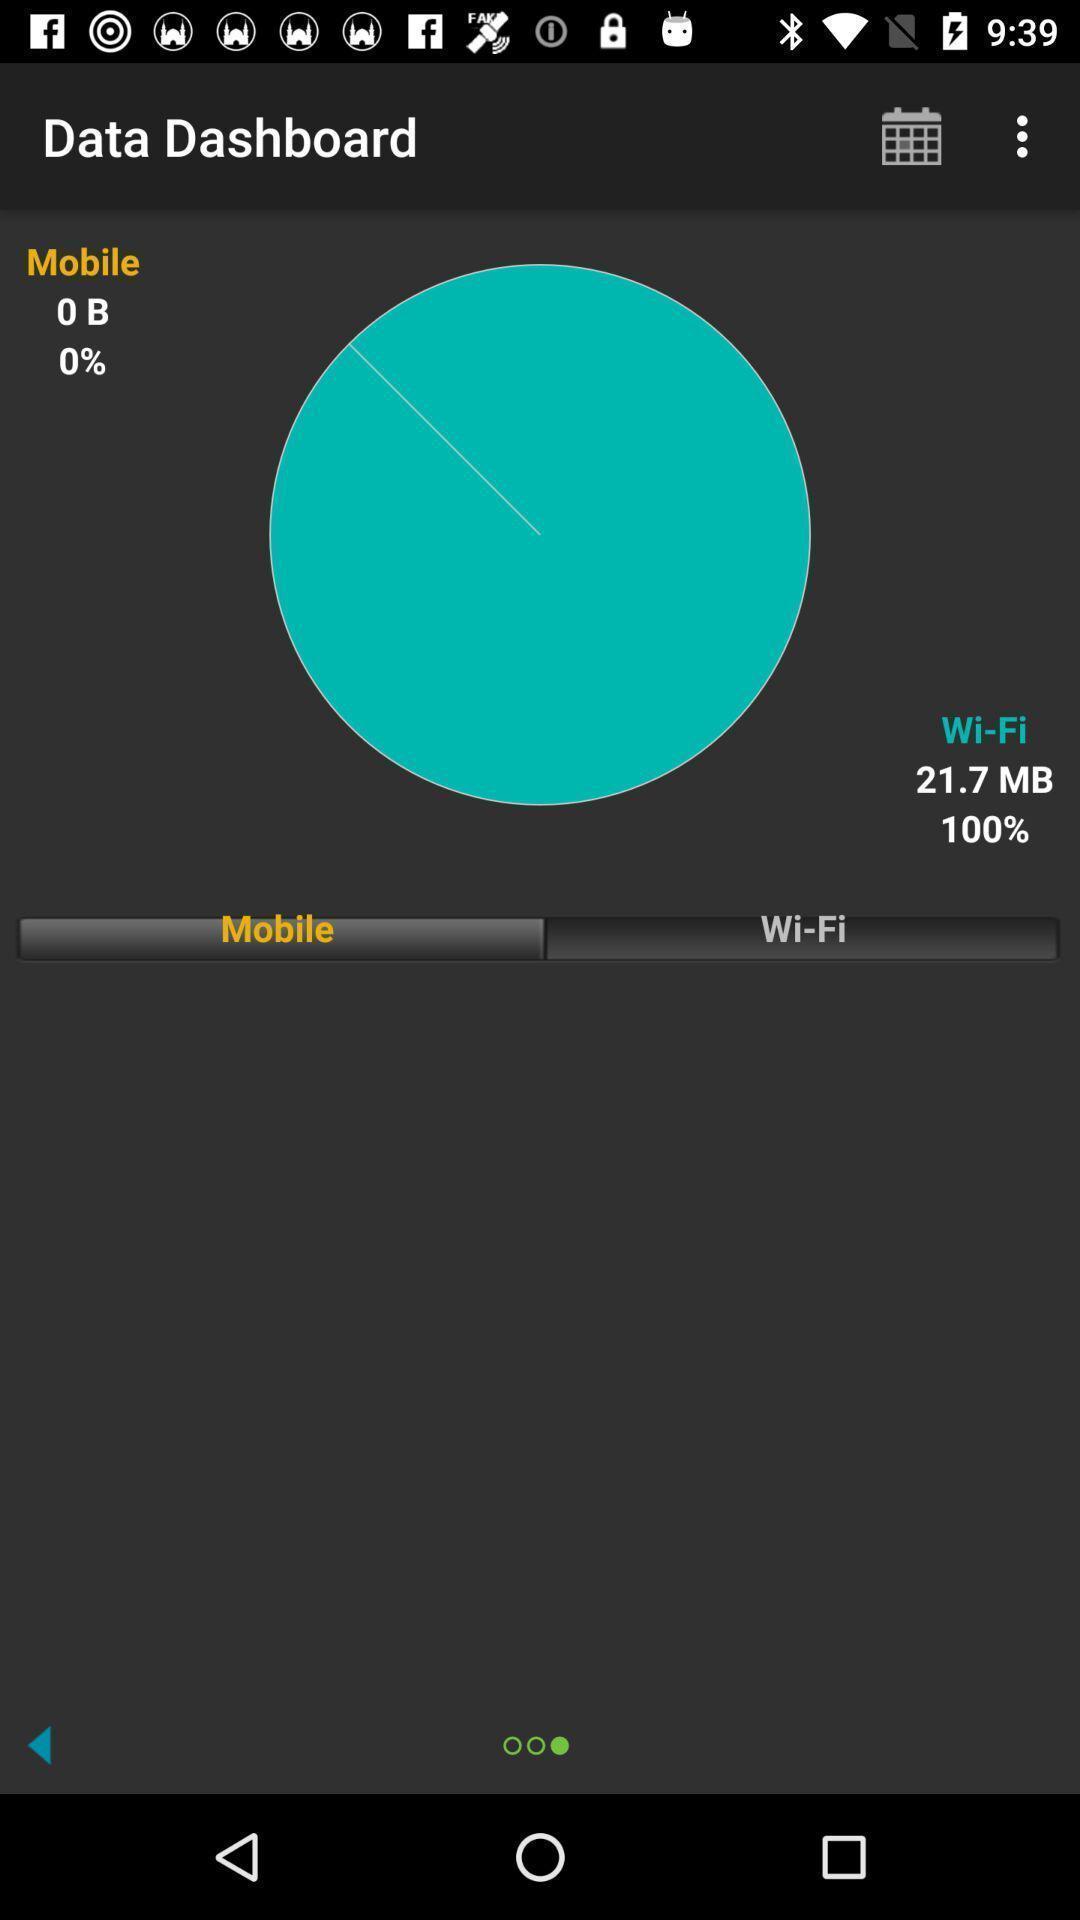Provide a textual representation of this image. Screen showing dashboard. 